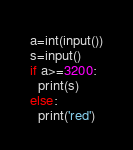<code> <loc_0><loc_0><loc_500><loc_500><_Python_>a=int(input())
s=input()
if a>=3200:
  print(s)
else:
  print('red')</code> 